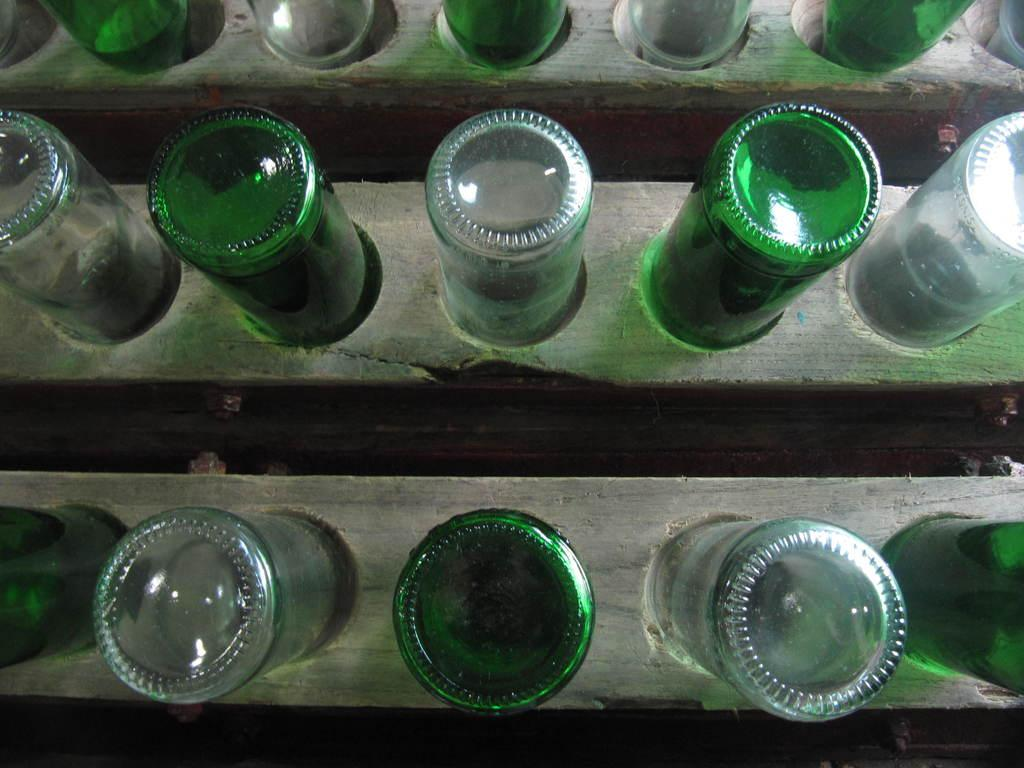What objects are present in the image? There are bottles in the image. Where are the bottles located? The bottles are in or near wood. How many pens can be seen in the image? There is no mention of pens in the provided facts, so we cannot determine the number of pens in the image. 